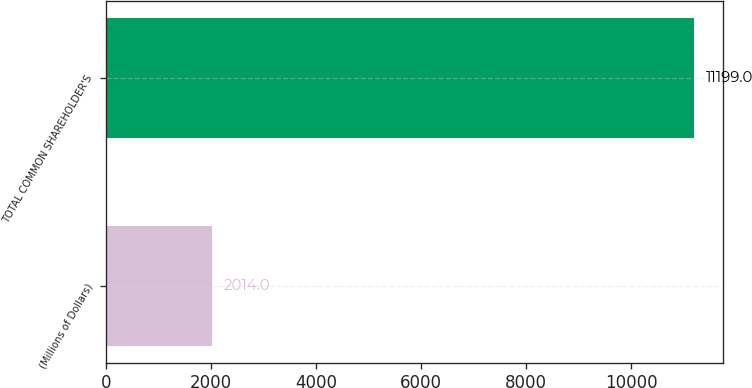Convert chart. <chart><loc_0><loc_0><loc_500><loc_500><bar_chart><fcel>(Millions of Dollars)<fcel>TOTAL COMMON SHAREHOLDER'S<nl><fcel>2014<fcel>11199<nl></chart> 